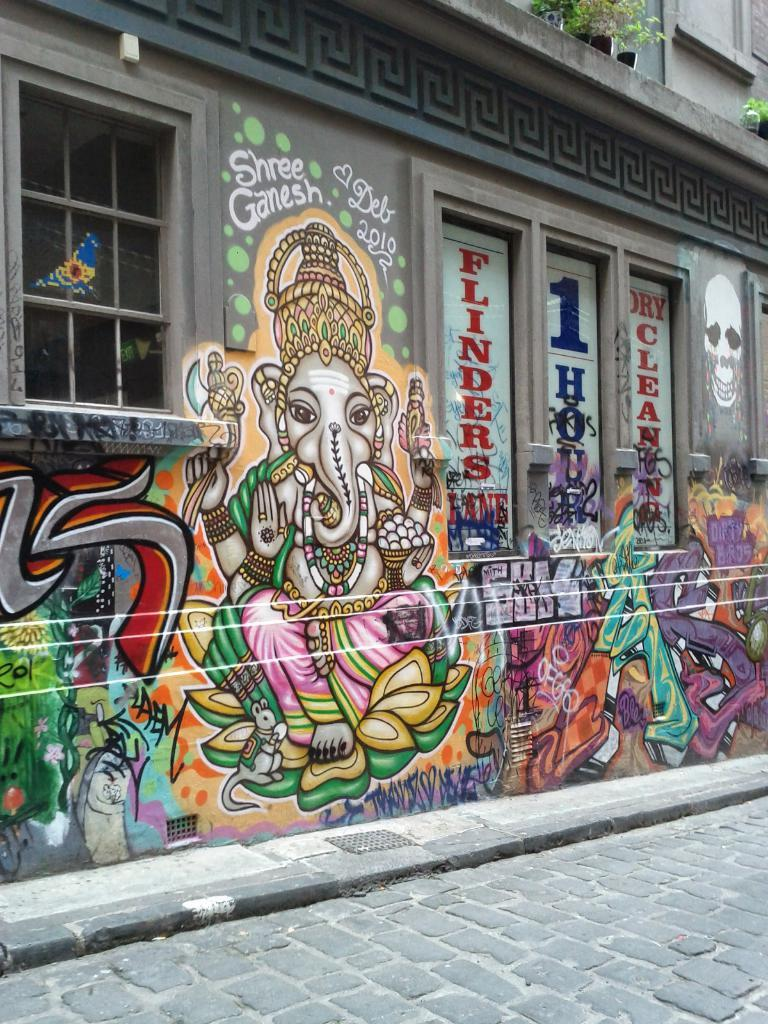What is depicted on the wall in the image? There is graffiti on a wall in the image. What architectural feature can be seen in the image? There are windows visible in the image. What type of vegetation is present at the top of the image? Plants are present at the top of the image. What type of trousers can be seen hanging from the plants in the image? There are no trousers present in the image, and they are not hanging from the plants. 